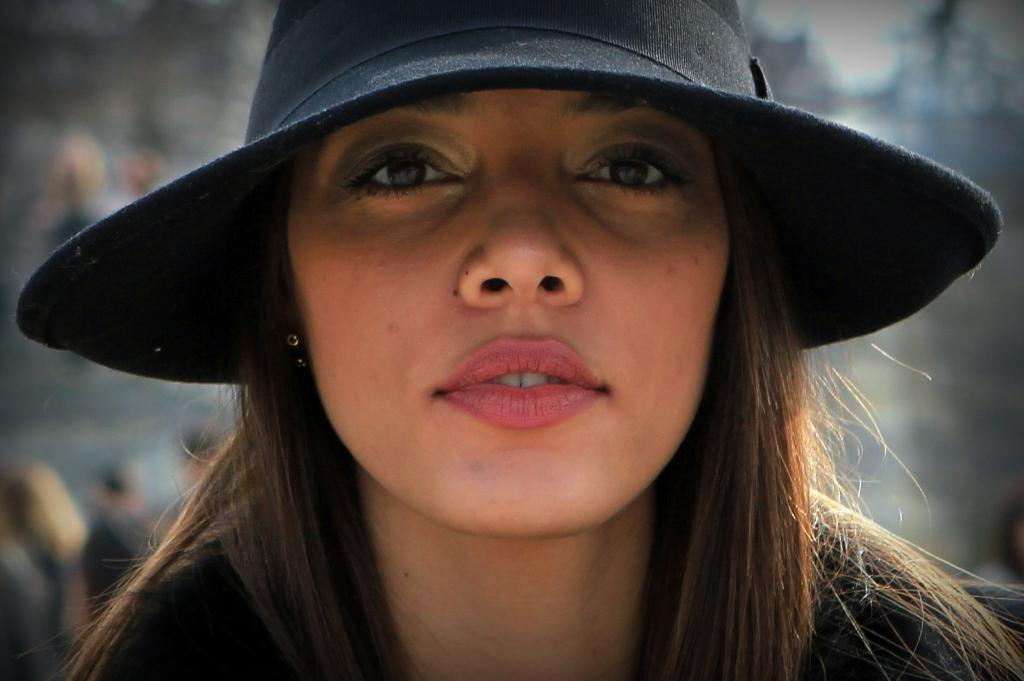Can you describe this image briefly? There is a woman wearing black hat. In the background it is blurred. 